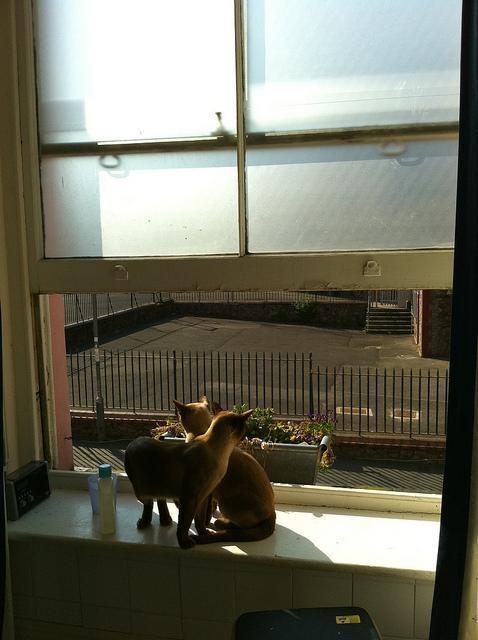How many Siamese cats are sitting atop the window cell?
Select the accurate answer and provide justification: `Answer: choice
Rationale: srationale.`
Options: One, two, four, three. Answer: two.
Rationale: There are two cats. 